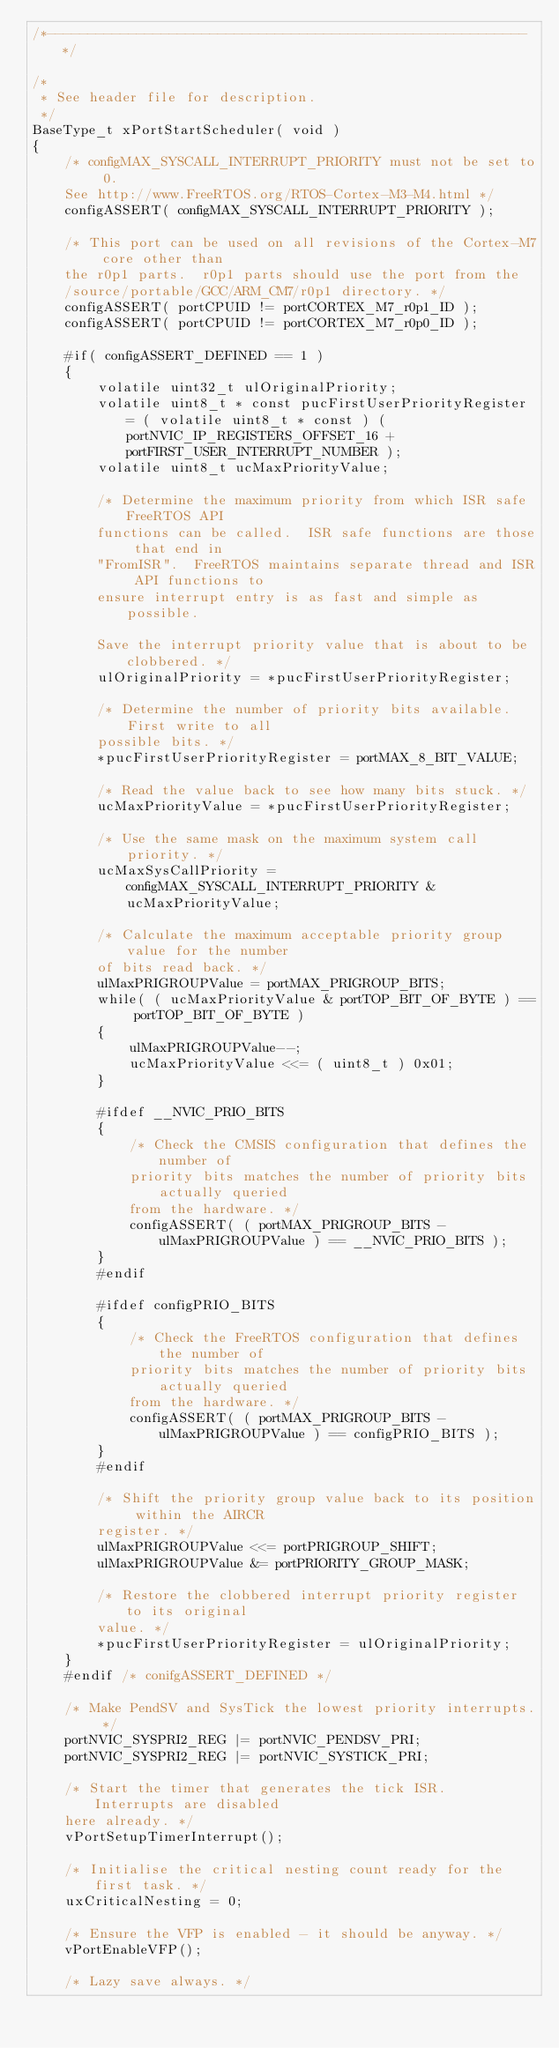<code> <loc_0><loc_0><loc_500><loc_500><_C_>/*-----------------------------------------------------------*/

/*
 * See header file for description.
 */
BaseType_t xPortStartScheduler( void )
{
	/* configMAX_SYSCALL_INTERRUPT_PRIORITY must not be set to 0.
	See http://www.FreeRTOS.org/RTOS-Cortex-M3-M4.html */
	configASSERT( configMAX_SYSCALL_INTERRUPT_PRIORITY );

	/* This port can be used on all revisions of the Cortex-M7 core other than
	the r0p1 parts.  r0p1 parts should use the port from the
	/source/portable/GCC/ARM_CM7/r0p1 directory. */
	configASSERT( portCPUID != portCORTEX_M7_r0p1_ID );
	configASSERT( portCPUID != portCORTEX_M7_r0p0_ID );

	#if( configASSERT_DEFINED == 1 )
	{
		volatile uint32_t ulOriginalPriority;
		volatile uint8_t * const pucFirstUserPriorityRegister = ( volatile uint8_t * const ) ( portNVIC_IP_REGISTERS_OFFSET_16 + portFIRST_USER_INTERRUPT_NUMBER );
		volatile uint8_t ucMaxPriorityValue;

		/* Determine the maximum priority from which ISR safe FreeRTOS API
		functions can be called.  ISR safe functions are those that end in
		"FromISR".  FreeRTOS maintains separate thread and ISR API functions to
		ensure interrupt entry is as fast and simple as possible.

		Save the interrupt priority value that is about to be clobbered. */
		ulOriginalPriority = *pucFirstUserPriorityRegister;

		/* Determine the number of priority bits available.  First write to all
		possible bits. */
		*pucFirstUserPriorityRegister = portMAX_8_BIT_VALUE;

		/* Read the value back to see how many bits stuck. */
		ucMaxPriorityValue = *pucFirstUserPriorityRegister;

		/* Use the same mask on the maximum system call priority. */
		ucMaxSysCallPriority = configMAX_SYSCALL_INTERRUPT_PRIORITY & ucMaxPriorityValue;

		/* Calculate the maximum acceptable priority group value for the number
		of bits read back. */
		ulMaxPRIGROUPValue = portMAX_PRIGROUP_BITS;
		while( ( ucMaxPriorityValue & portTOP_BIT_OF_BYTE ) == portTOP_BIT_OF_BYTE )
		{
			ulMaxPRIGROUPValue--;
			ucMaxPriorityValue <<= ( uint8_t ) 0x01;
		}

		#ifdef __NVIC_PRIO_BITS
		{
			/* Check the CMSIS configuration that defines the number of
			priority bits matches the number of priority bits actually queried
			from the hardware. */
			configASSERT( ( portMAX_PRIGROUP_BITS - ulMaxPRIGROUPValue ) == __NVIC_PRIO_BITS );
		}
		#endif

		#ifdef configPRIO_BITS
		{
			/* Check the FreeRTOS configuration that defines the number of
			priority bits matches the number of priority bits actually queried
			from the hardware. */
			configASSERT( ( portMAX_PRIGROUP_BITS - ulMaxPRIGROUPValue ) == configPRIO_BITS );
		}
		#endif

		/* Shift the priority group value back to its position within the AIRCR
		register. */
		ulMaxPRIGROUPValue <<= portPRIGROUP_SHIFT;
		ulMaxPRIGROUPValue &= portPRIORITY_GROUP_MASK;

		/* Restore the clobbered interrupt priority register to its original
		value. */
		*pucFirstUserPriorityRegister = ulOriginalPriority;
	}
	#endif /* conifgASSERT_DEFINED */

	/* Make PendSV and SysTick the lowest priority interrupts. */
	portNVIC_SYSPRI2_REG |= portNVIC_PENDSV_PRI;
	portNVIC_SYSPRI2_REG |= portNVIC_SYSTICK_PRI;

	/* Start the timer that generates the tick ISR.  Interrupts are disabled
	here already. */
	vPortSetupTimerInterrupt();

	/* Initialise the critical nesting count ready for the first task. */
	uxCriticalNesting = 0;

	/* Ensure the VFP is enabled - it should be anyway. */
	vPortEnableVFP();

	/* Lazy save always. */</code> 